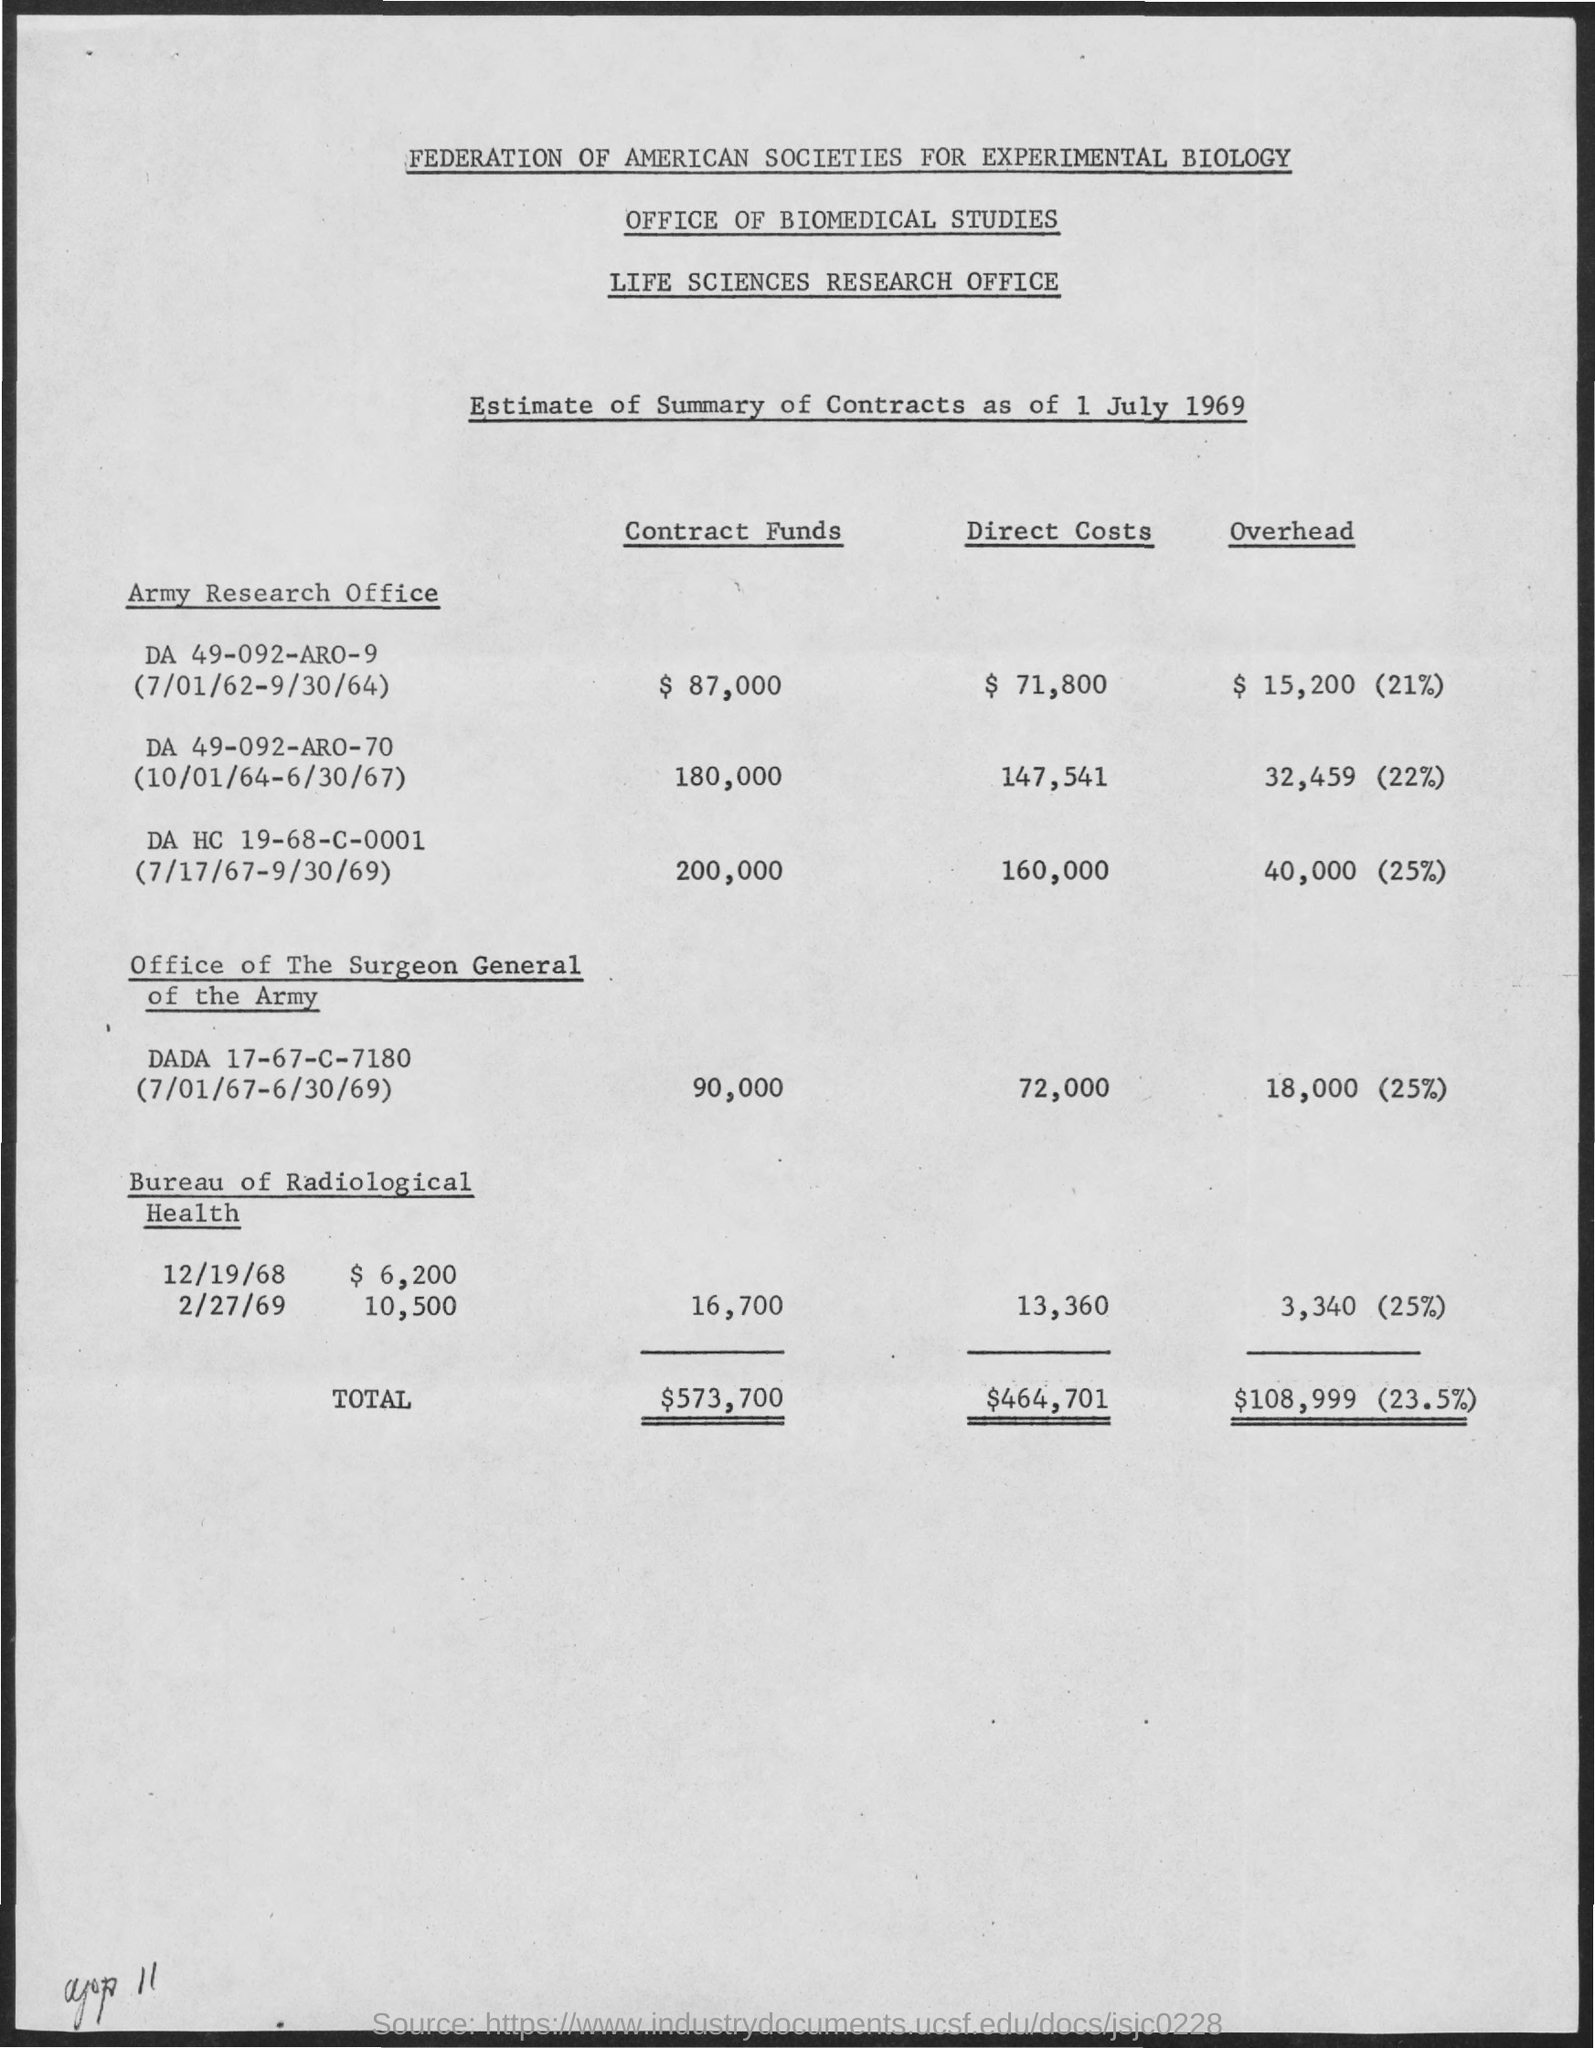What are the Contract funds for Army research office DA 49-092-ARO-9 (7/01/62-9/30/64)?
Give a very brief answer. 87,000. What are the Direct Costs for Army research office DA 49-092-ARO-9 (7/01/62-9/30/64)?
Keep it short and to the point. $ 71,800. What are the Overhead for Army research office DA 49-092-ARO-9 (7/01/62-9/30/64)?
Your answer should be compact. $ 15,200 (21%). What are the Contract funds for Army research office DA 49-092-ARO-70 (10/01/64-6/30/67)?
Make the answer very short. 180,000. What are the Direct Costs for Army research office DA 49-092-ARO-70 (10/01/64-6/30/67)?
Offer a terse response. 147,541. What are the Overhead for Army research office DA 49-092-ARO-70 (10/01/64-6/30/67)?
Offer a very short reply. 32,459. What is the total for contract funds?
Offer a terse response. $573,700. What is the total for Direct costs?
Your answer should be compact. $464,701. What is the Total for overhead?
Ensure brevity in your answer.  $108,999 (23.5%). 